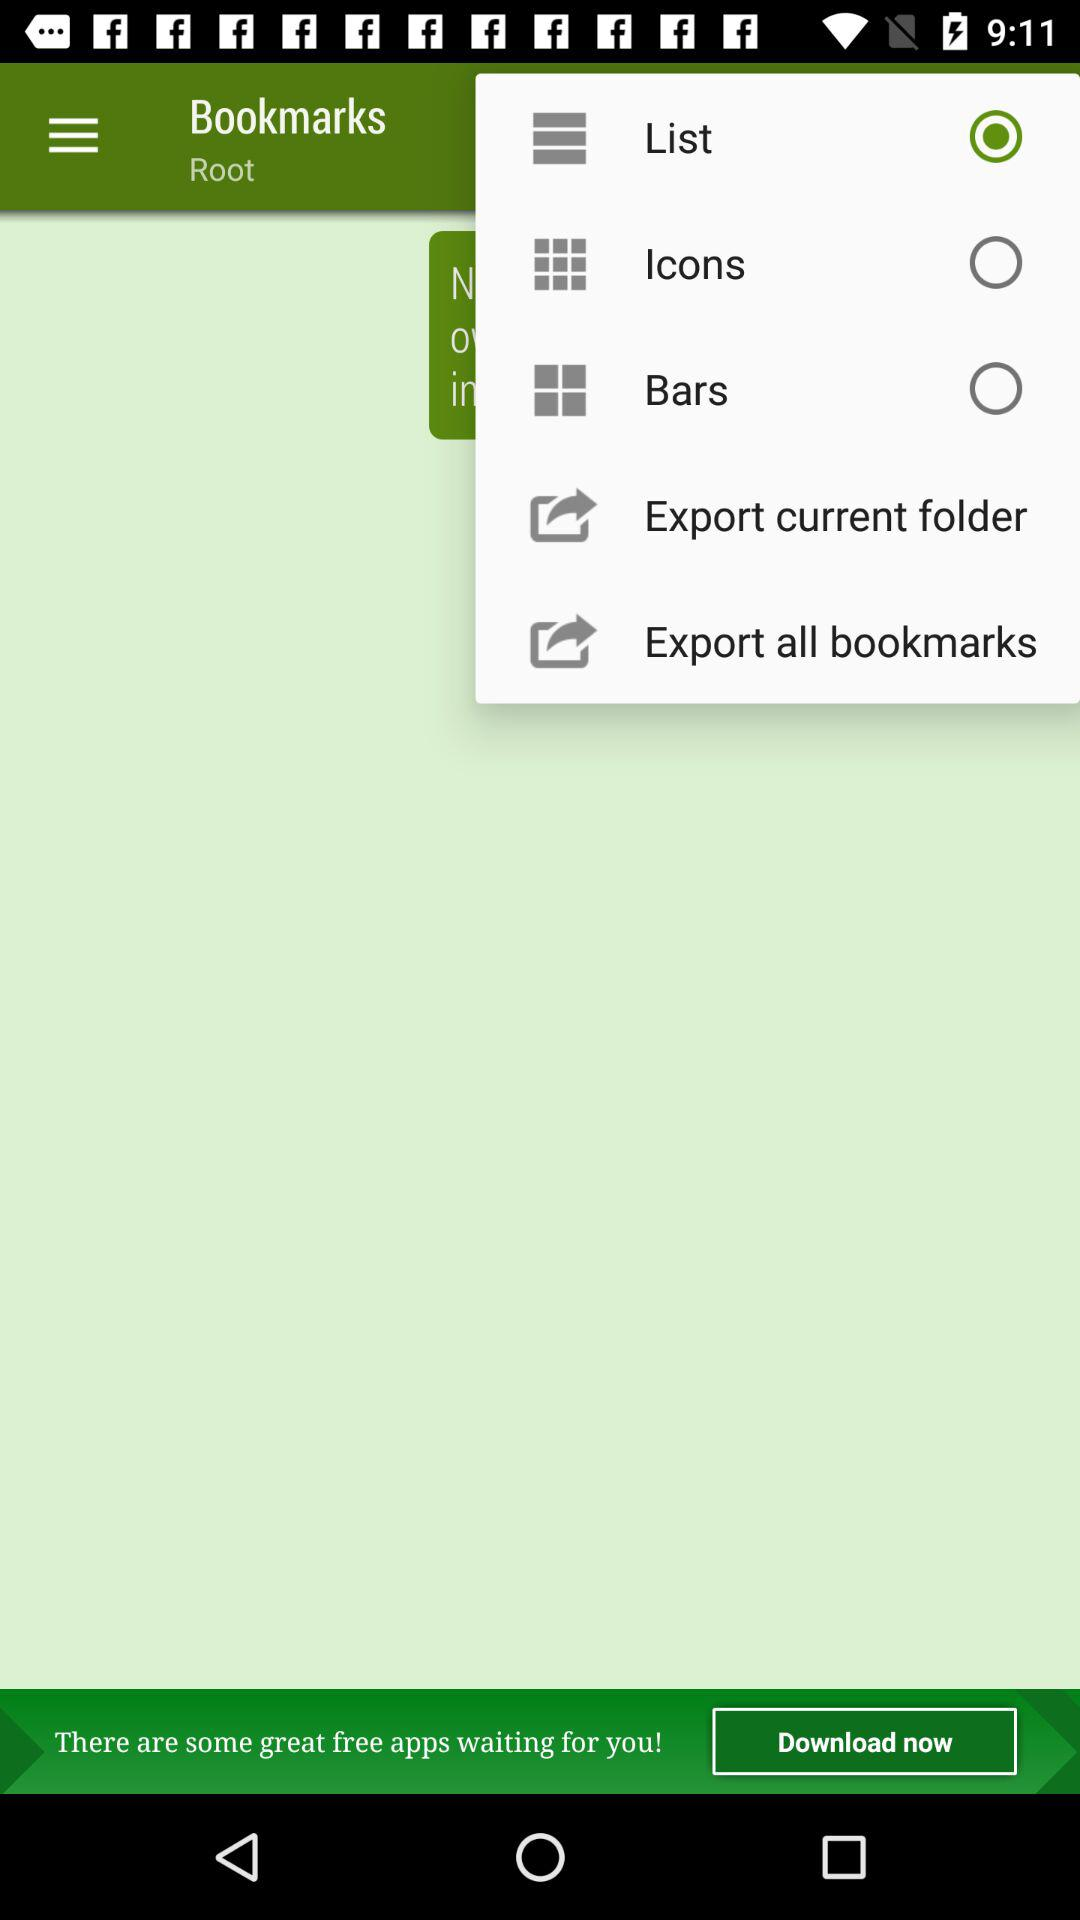Is "Bars" selected or not? "Bars" is not selected. 